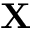Convert formula to latex. <formula><loc_0><loc_0><loc_500><loc_500>X</formula> 